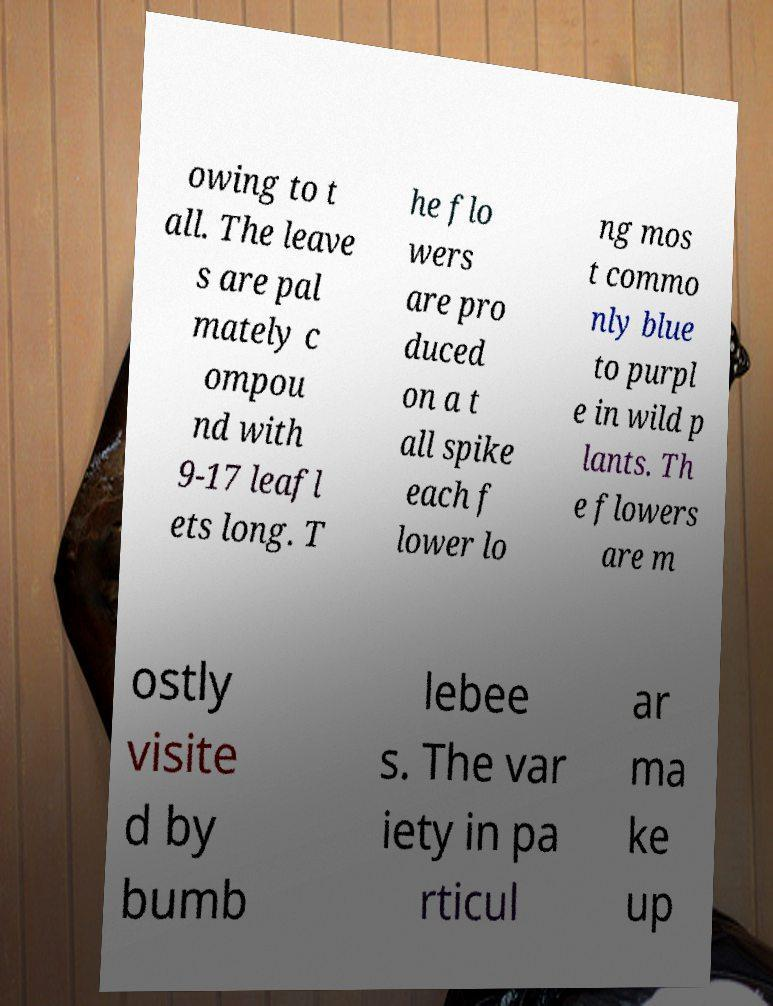For documentation purposes, I need the text within this image transcribed. Could you provide that? owing to t all. The leave s are pal mately c ompou nd with 9-17 leafl ets long. T he flo wers are pro duced on a t all spike each f lower lo ng mos t commo nly blue to purpl e in wild p lants. Th e flowers are m ostly visite d by bumb lebee s. The var iety in pa rticul ar ma ke up 